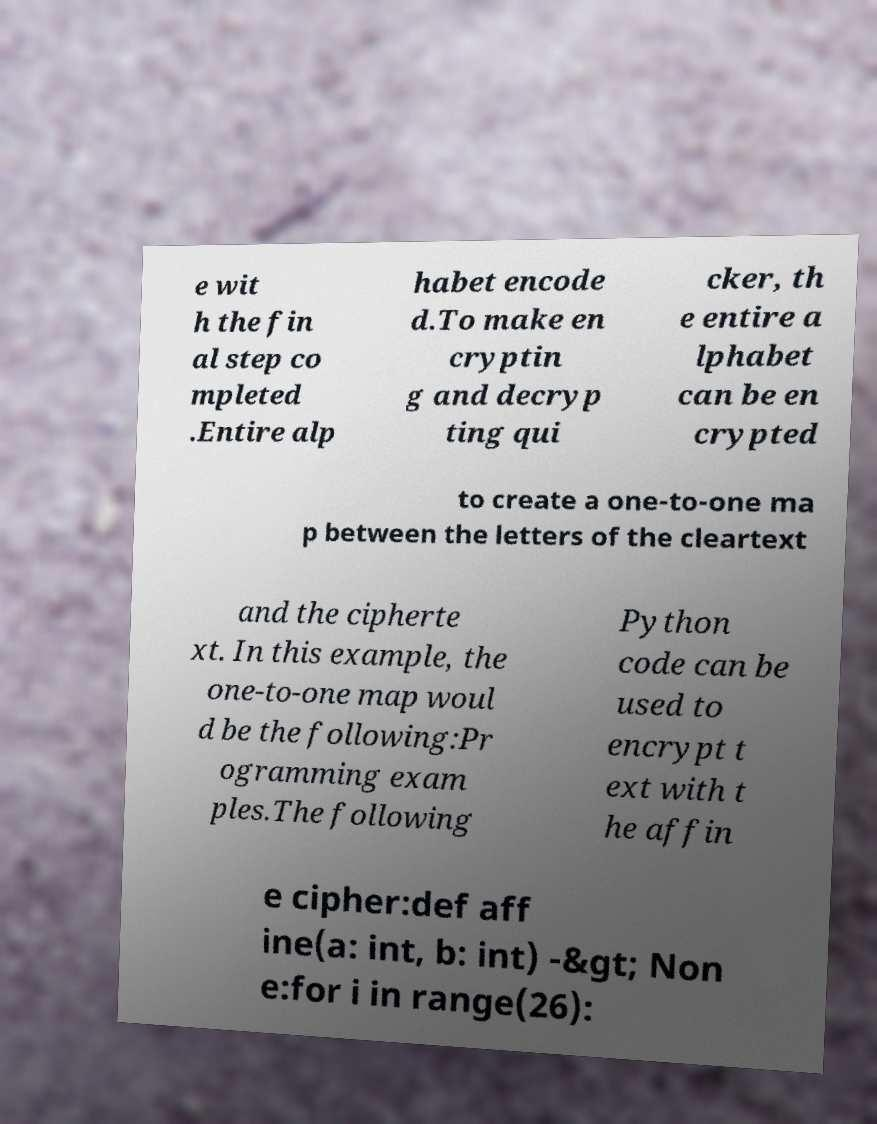Could you extract and type out the text from this image? e wit h the fin al step co mpleted .Entire alp habet encode d.To make en cryptin g and decryp ting qui cker, th e entire a lphabet can be en crypted to create a one-to-one ma p between the letters of the cleartext and the cipherte xt. In this example, the one-to-one map woul d be the following:Pr ogramming exam ples.The following Python code can be used to encrypt t ext with t he affin e cipher:def aff ine(a: int, b: int) -&gt; Non e:for i in range(26): 